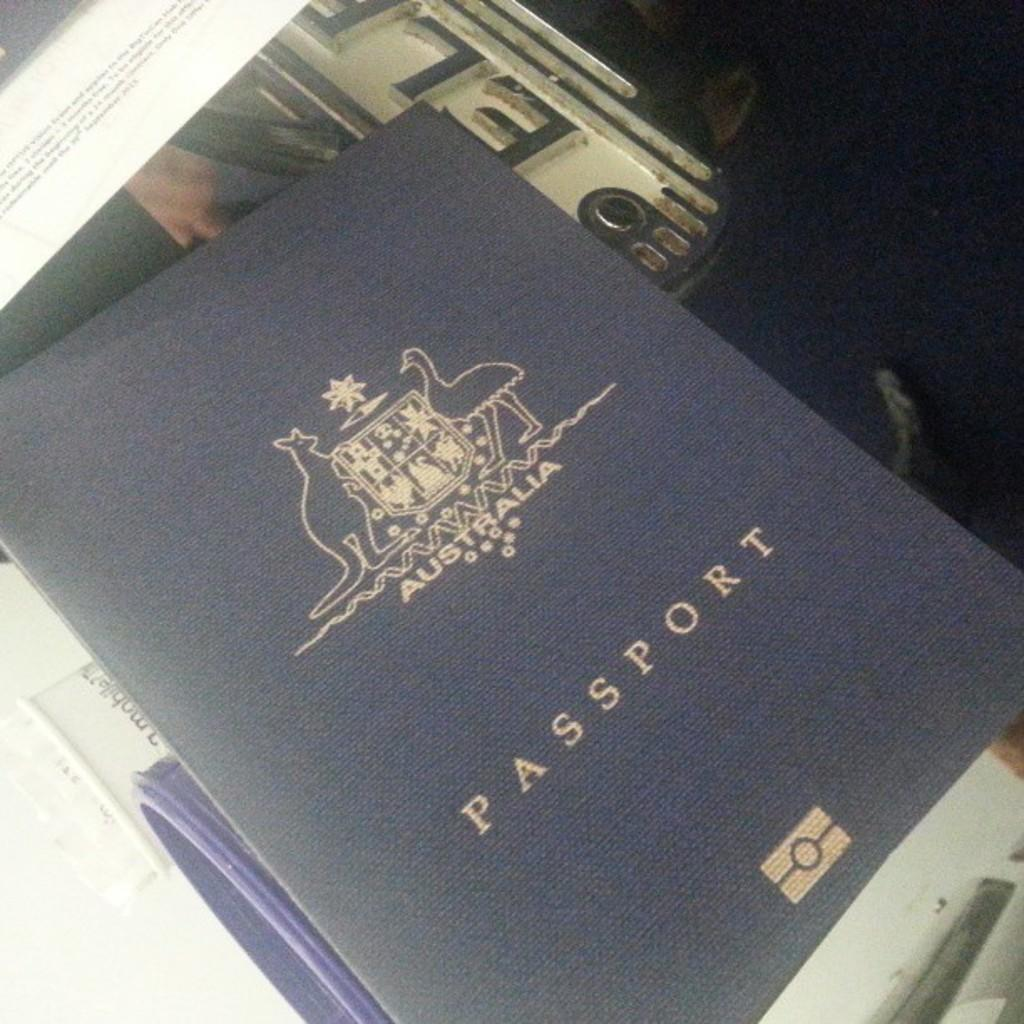Provide a one-sentence caption for the provided image. the word passport is on the blue item. 